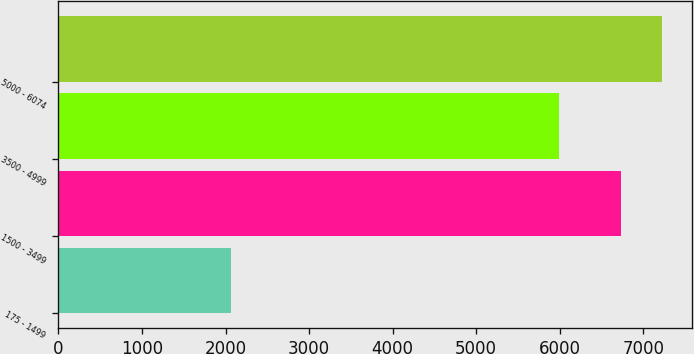<chart> <loc_0><loc_0><loc_500><loc_500><bar_chart><fcel>175 - 1499<fcel>1500 - 3499<fcel>3500 - 4999<fcel>5000 - 6074<nl><fcel>2064<fcel>6737<fcel>5992<fcel>7227.3<nl></chart> 